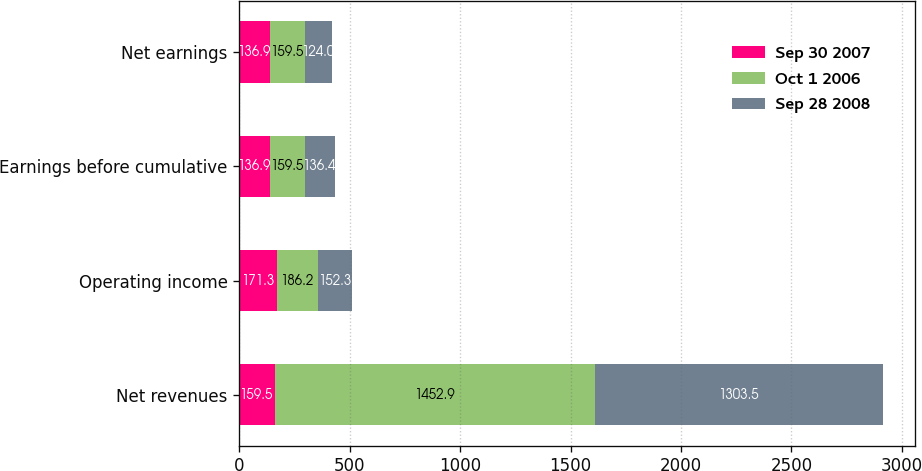<chart> <loc_0><loc_0><loc_500><loc_500><stacked_bar_chart><ecel><fcel>Net revenues<fcel>Operating income<fcel>Earnings before cumulative<fcel>Net earnings<nl><fcel>Sep 30 2007<fcel>159.5<fcel>171.3<fcel>136.9<fcel>136.9<nl><fcel>Oct 1 2006<fcel>1452.9<fcel>186.2<fcel>159.5<fcel>159.5<nl><fcel>Sep 28 2008<fcel>1303.5<fcel>152.3<fcel>136.4<fcel>124<nl></chart> 